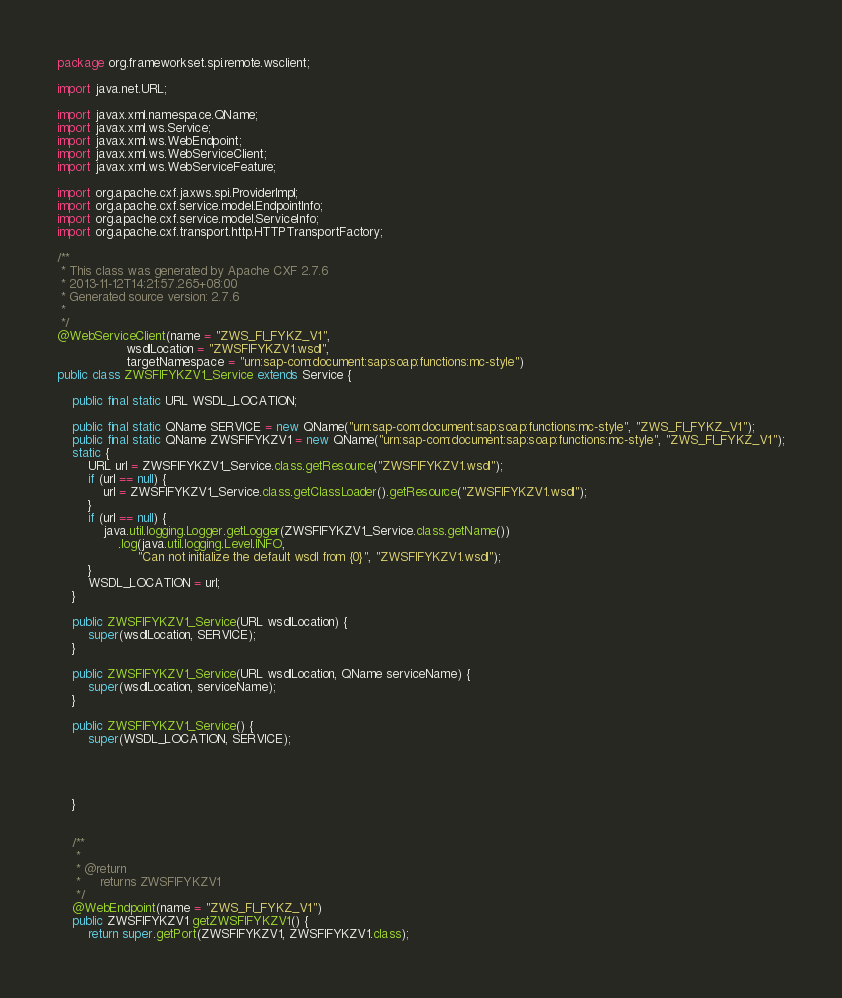Convert code to text. <code><loc_0><loc_0><loc_500><loc_500><_Java_>package org.frameworkset.spi.remote.wsclient;

import java.net.URL;

import javax.xml.namespace.QName;
import javax.xml.ws.Service;
import javax.xml.ws.WebEndpoint;
import javax.xml.ws.WebServiceClient;
import javax.xml.ws.WebServiceFeature;

import org.apache.cxf.jaxws.spi.ProviderImpl;
import org.apache.cxf.service.model.EndpointInfo;
import org.apache.cxf.service.model.ServiceInfo;
import org.apache.cxf.transport.http.HTTPTransportFactory;

/**
 * This class was generated by Apache CXF 2.7.6
 * 2013-11-12T14:21:57.265+08:00
 * Generated source version: 2.7.6
 * 
 */
@WebServiceClient(name = "ZWS_FI_FYKZ_V1", 
                  wsdlLocation = "ZWSFIFYKZV1.wsdl",
                  targetNamespace = "urn:sap-com:document:sap:soap:functions:mc-style") 
public class ZWSFIFYKZV1_Service extends Service {

    public final static URL WSDL_LOCATION;

    public final static QName SERVICE = new QName("urn:sap-com:document:sap:soap:functions:mc-style", "ZWS_FI_FYKZ_V1");
    public final static QName ZWSFIFYKZV1 = new QName("urn:sap-com:document:sap:soap:functions:mc-style", "ZWS_FI_FYKZ_V1");
    static {
        URL url = ZWSFIFYKZV1_Service.class.getResource("ZWSFIFYKZV1.wsdl");
        if (url == null) {
            url = ZWSFIFYKZV1_Service.class.getClassLoader().getResource("ZWSFIFYKZV1.wsdl");
        } 
        if (url == null) {
            java.util.logging.Logger.getLogger(ZWSFIFYKZV1_Service.class.getName())
                .log(java.util.logging.Level.INFO, 
                     "Can not initialize the default wsdl from {0}", "ZWSFIFYKZV1.wsdl");
        }       
        WSDL_LOCATION = url;
    }

    public ZWSFIFYKZV1_Service(URL wsdlLocation) {
        super(wsdlLocation, SERVICE);
    }

    public ZWSFIFYKZV1_Service(URL wsdlLocation, QName serviceName) {
        super(wsdlLocation, serviceName);
    }

    public ZWSFIFYKZV1_Service() {
        super(WSDL_LOCATION, SERVICE);
        

        

    }
    

    /**
     *
     * @return
     *     returns ZWSFIFYKZV1
     */
    @WebEndpoint(name = "ZWS_FI_FYKZ_V1")
    public ZWSFIFYKZV1 getZWSFIFYKZV1() {
        return super.getPort(ZWSFIFYKZV1, ZWSFIFYKZV1.class);</code> 